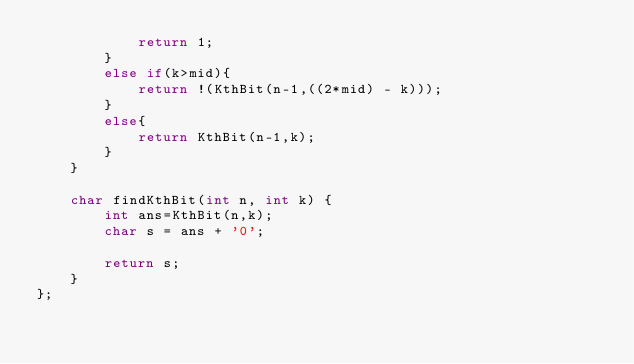Convert code to text. <code><loc_0><loc_0><loc_500><loc_500><_C++_>            return 1;
        }
        else if(k>mid){
            return !(KthBit(n-1,((2*mid) - k)));
        }
        else{
            return KthBit(n-1,k);
        }
    }
    
    char findKthBit(int n, int k) {
        int ans=KthBit(n,k);   
        char s = ans + '0';
        
        return s;
    }
};</code> 